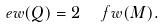Convert formula to latex. <formula><loc_0><loc_0><loc_500><loc_500>\ e w ( Q ) = 2 \ \, \ f w ( M ) .</formula> 